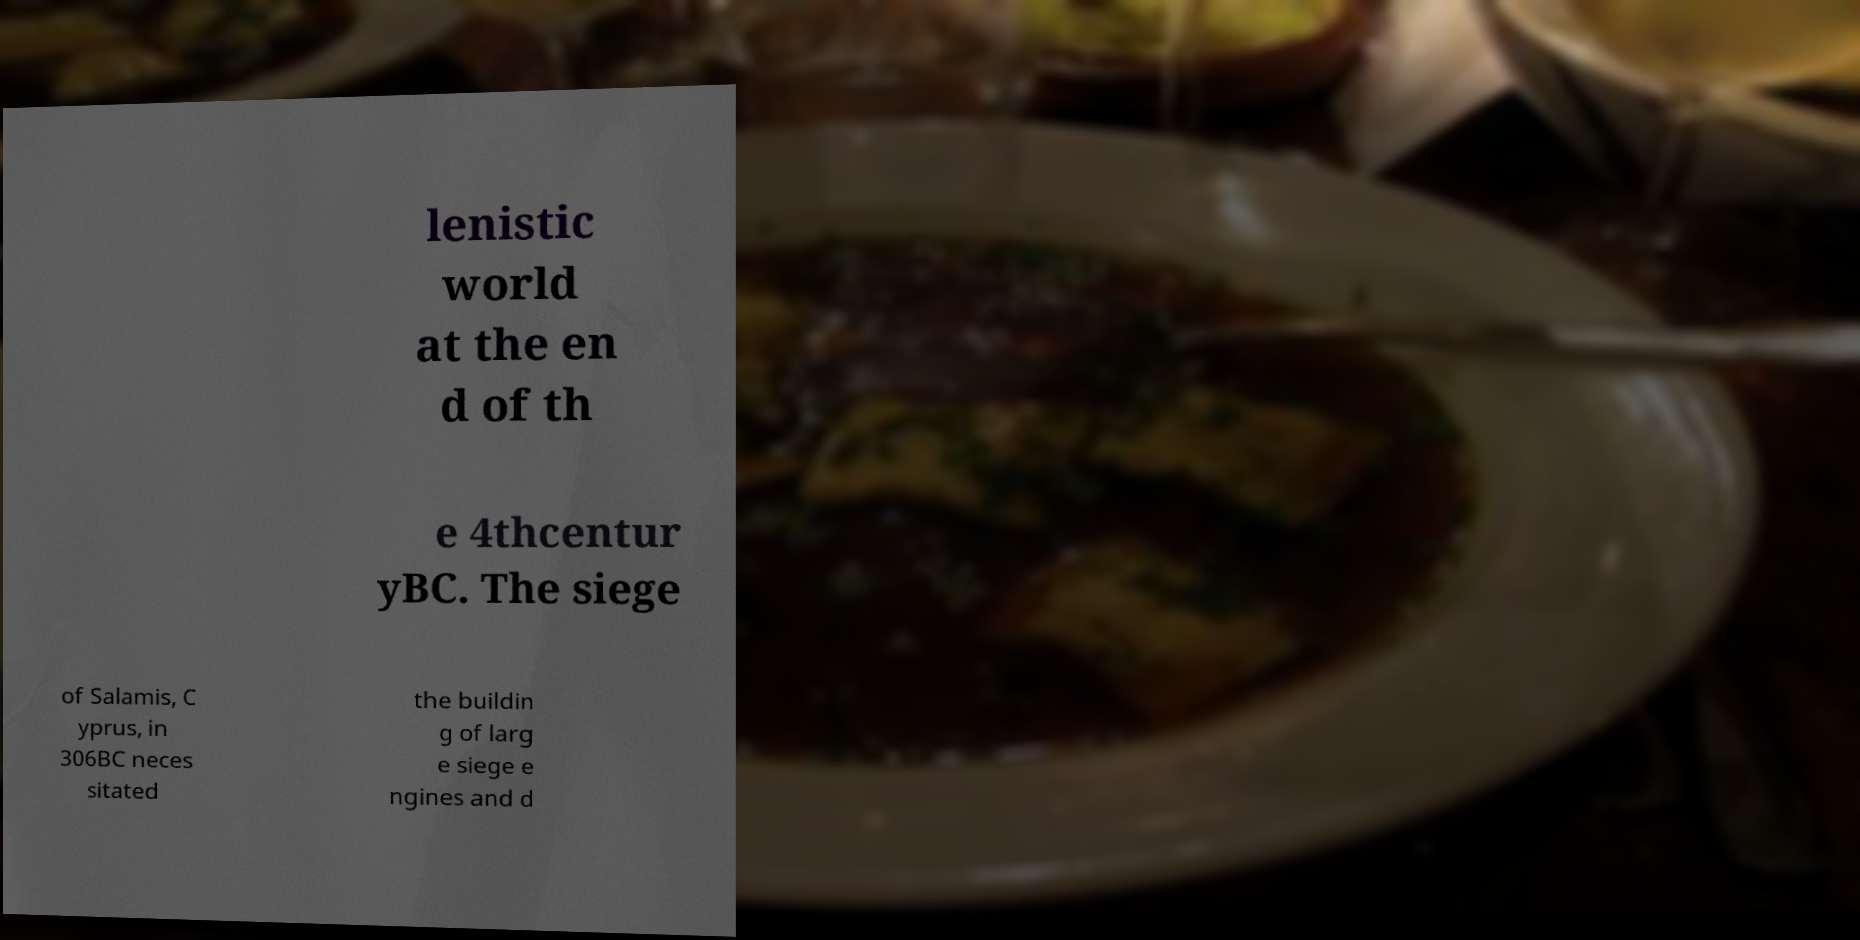Could you extract and type out the text from this image? lenistic world at the en d of th e 4thcentur yBC. The siege of Salamis, C yprus, in 306BC neces sitated the buildin g of larg e siege e ngines and d 